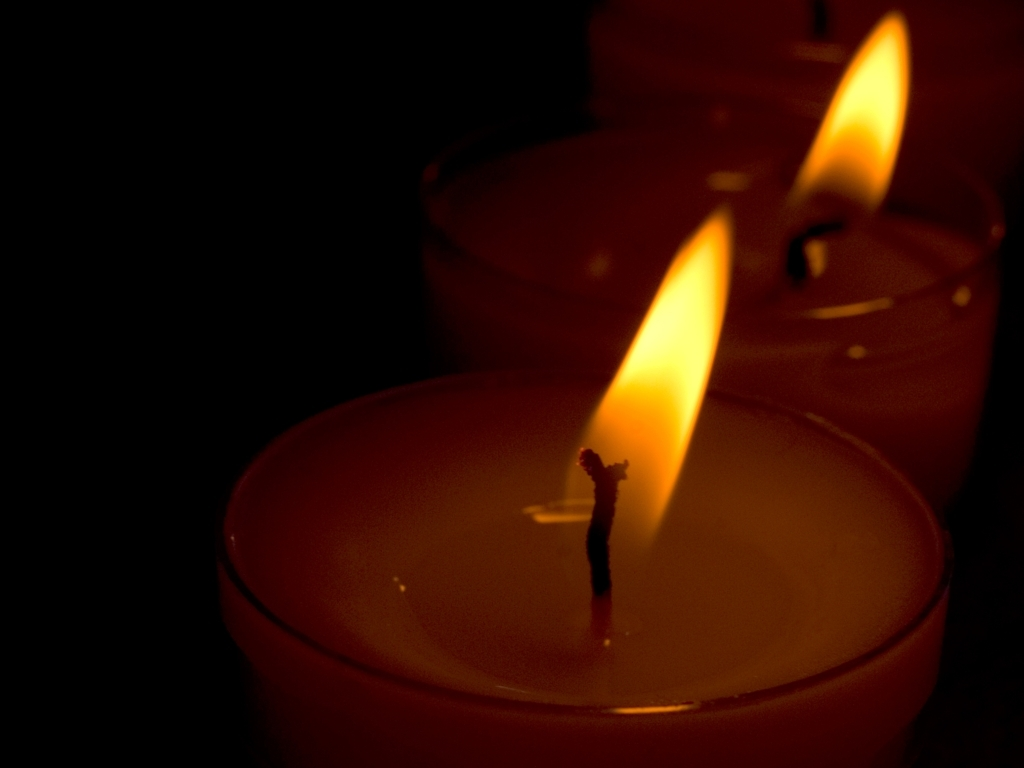How could this image be improved for better visual quality? For enhanced visual quality, the photographer could consider increasing the exposure to reveal more detail in the shadow areas without overexposing the flames. A lower ISO setting might reduce the graininess for a cleaner look. Additionally, compositionally, including more surrounding context or using a wider aperture to soften the background further could add to the aesthetic appeal. 